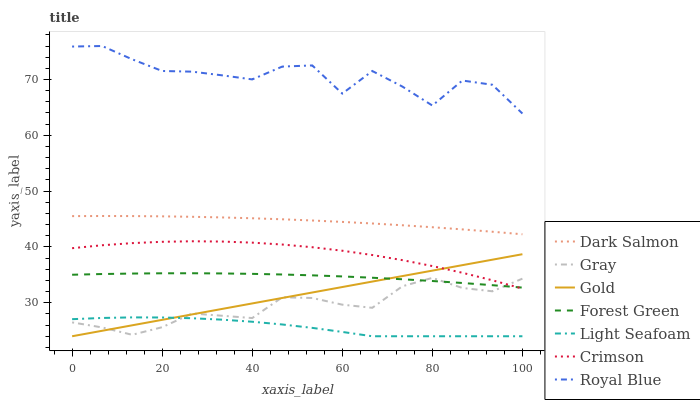Does Light Seafoam have the minimum area under the curve?
Answer yes or no. Yes. Does Royal Blue have the maximum area under the curve?
Answer yes or no. Yes. Does Gold have the minimum area under the curve?
Answer yes or no. No. Does Gold have the maximum area under the curve?
Answer yes or no. No. Is Gold the smoothest?
Answer yes or no. Yes. Is Royal Blue the roughest?
Answer yes or no. Yes. Is Dark Salmon the smoothest?
Answer yes or no. No. Is Dark Salmon the roughest?
Answer yes or no. No. Does Gold have the lowest value?
Answer yes or no. Yes. Does Dark Salmon have the lowest value?
Answer yes or no. No. Does Royal Blue have the highest value?
Answer yes or no. Yes. Does Gold have the highest value?
Answer yes or no. No. Is Light Seafoam less than Royal Blue?
Answer yes or no. Yes. Is Forest Green greater than Light Seafoam?
Answer yes or no. Yes. Does Gray intersect Light Seafoam?
Answer yes or no. Yes. Is Gray less than Light Seafoam?
Answer yes or no. No. Is Gray greater than Light Seafoam?
Answer yes or no. No. Does Light Seafoam intersect Royal Blue?
Answer yes or no. No. 